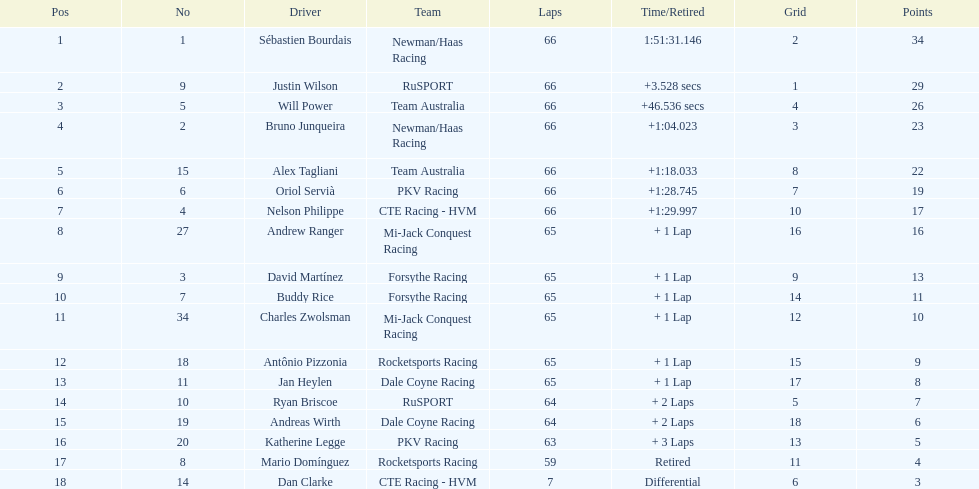At the 2006 gran premio telmex, who scored the highest number of points? Sébastien Bourdais. 